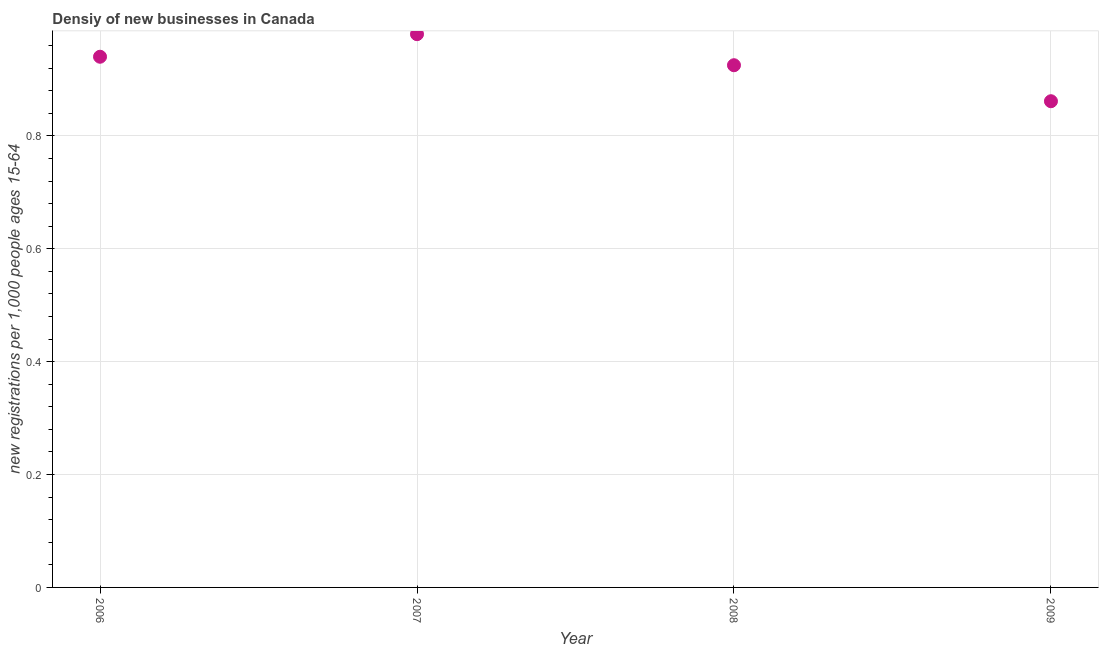What is the density of new business in 2007?
Make the answer very short. 0.98. Across all years, what is the maximum density of new business?
Ensure brevity in your answer.  0.98. Across all years, what is the minimum density of new business?
Your answer should be compact. 0.86. In which year was the density of new business maximum?
Give a very brief answer. 2007. In which year was the density of new business minimum?
Give a very brief answer. 2009. What is the sum of the density of new business?
Offer a very short reply. 3.71. What is the difference between the density of new business in 2008 and 2009?
Offer a terse response. 0.06. What is the average density of new business per year?
Make the answer very short. 0.93. What is the median density of new business?
Your response must be concise. 0.93. In how many years, is the density of new business greater than 0.24000000000000002 ?
Give a very brief answer. 4. What is the ratio of the density of new business in 2007 to that in 2008?
Your answer should be very brief. 1.06. What is the difference between the highest and the second highest density of new business?
Your answer should be very brief. 0.04. Is the sum of the density of new business in 2008 and 2009 greater than the maximum density of new business across all years?
Give a very brief answer. Yes. What is the difference between the highest and the lowest density of new business?
Offer a very short reply. 0.12. How many dotlines are there?
Make the answer very short. 1. How many years are there in the graph?
Provide a short and direct response. 4. Are the values on the major ticks of Y-axis written in scientific E-notation?
Provide a short and direct response. No. Does the graph contain any zero values?
Offer a very short reply. No. What is the title of the graph?
Your answer should be compact. Densiy of new businesses in Canada. What is the label or title of the X-axis?
Your answer should be very brief. Year. What is the label or title of the Y-axis?
Your answer should be very brief. New registrations per 1,0 people ages 15-64. What is the new registrations per 1,000 people ages 15-64 in 2006?
Offer a terse response. 0.94. What is the new registrations per 1,000 people ages 15-64 in 2007?
Your answer should be compact. 0.98. What is the new registrations per 1,000 people ages 15-64 in 2008?
Provide a short and direct response. 0.93. What is the new registrations per 1,000 people ages 15-64 in 2009?
Make the answer very short. 0.86. What is the difference between the new registrations per 1,000 people ages 15-64 in 2006 and 2007?
Keep it short and to the point. -0.04. What is the difference between the new registrations per 1,000 people ages 15-64 in 2006 and 2008?
Make the answer very short. 0.02. What is the difference between the new registrations per 1,000 people ages 15-64 in 2006 and 2009?
Provide a short and direct response. 0.08. What is the difference between the new registrations per 1,000 people ages 15-64 in 2007 and 2008?
Your answer should be very brief. 0.06. What is the difference between the new registrations per 1,000 people ages 15-64 in 2007 and 2009?
Ensure brevity in your answer.  0.12. What is the difference between the new registrations per 1,000 people ages 15-64 in 2008 and 2009?
Your answer should be very brief. 0.06. What is the ratio of the new registrations per 1,000 people ages 15-64 in 2006 to that in 2007?
Offer a very short reply. 0.96. What is the ratio of the new registrations per 1,000 people ages 15-64 in 2006 to that in 2009?
Your answer should be compact. 1.09. What is the ratio of the new registrations per 1,000 people ages 15-64 in 2007 to that in 2008?
Provide a succinct answer. 1.06. What is the ratio of the new registrations per 1,000 people ages 15-64 in 2007 to that in 2009?
Provide a succinct answer. 1.14. What is the ratio of the new registrations per 1,000 people ages 15-64 in 2008 to that in 2009?
Your answer should be very brief. 1.07. 